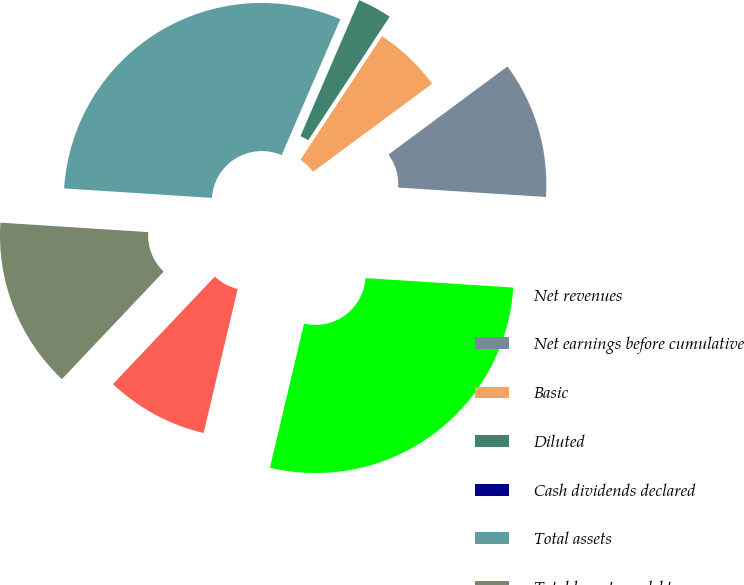Convert chart. <chart><loc_0><loc_0><loc_500><loc_500><pie_chart><fcel>Net revenues<fcel>Net earnings before cumulative<fcel>Basic<fcel>Diluted<fcel>Cash dividends declared<fcel>Total assets<fcel>Total long-term debt<fcel>Ratio of Earnings to Fixed<nl><fcel>27.68%<fcel>11.16%<fcel>5.58%<fcel>2.79%<fcel>0.0%<fcel>30.47%<fcel>13.95%<fcel>8.37%<nl></chart> 